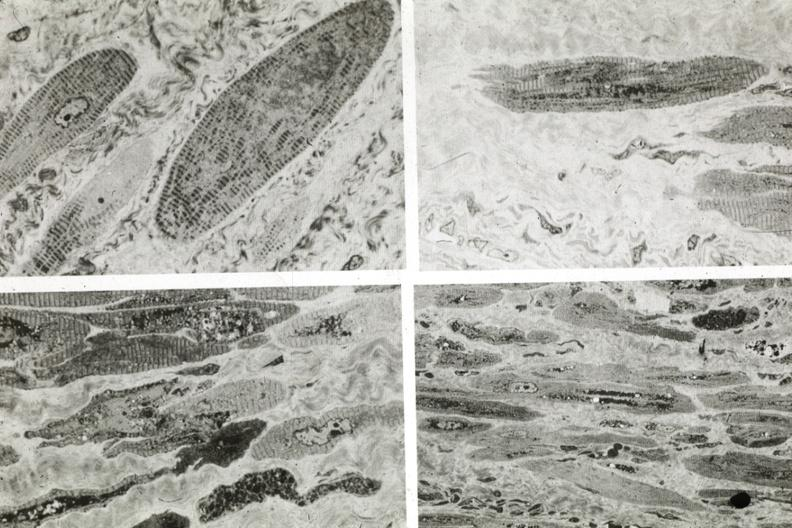s sacrococcygeal teratoma present?
Answer the question using a single word or phrase. No 